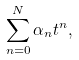<formula> <loc_0><loc_0><loc_500><loc_500>\sum _ { n = 0 } ^ { N } \alpha _ { n } t ^ { n } ,</formula> 